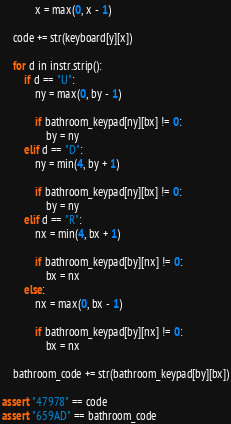<code> <loc_0><loc_0><loc_500><loc_500><_Python_>            x = max(0, x - 1)

    code += str(keyboard[y][x])

    for d in instr.strip():
        if d == "U":
            ny = max(0, by - 1)

            if bathroom_keypad[ny][bx] != 0:
                by = ny
        elif d == "D":
            ny = min(4, by + 1)

            if bathroom_keypad[ny][bx] != 0:
                by = ny
        elif d == "R":
            nx = min(4, bx + 1)

            if bathroom_keypad[by][nx] != 0:
                bx = nx
        else:
            nx = max(0, bx - 1)

            if bathroom_keypad[by][nx] != 0:
                bx = nx

    bathroom_code += str(bathroom_keypad[by][bx])

assert "47978" == code
assert "659AD" == bathroom_code
</code> 